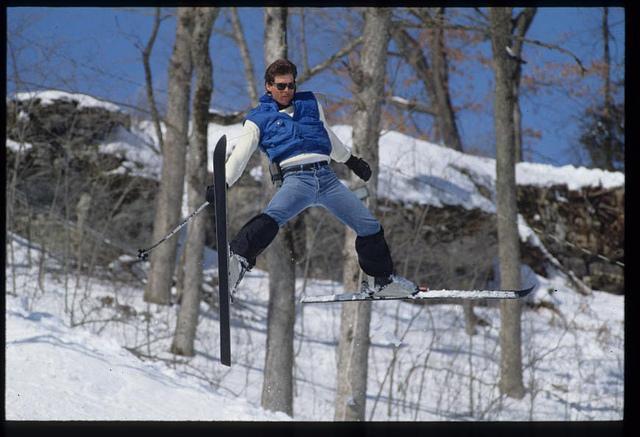How many ski can you see?
Give a very brief answer. 1. 